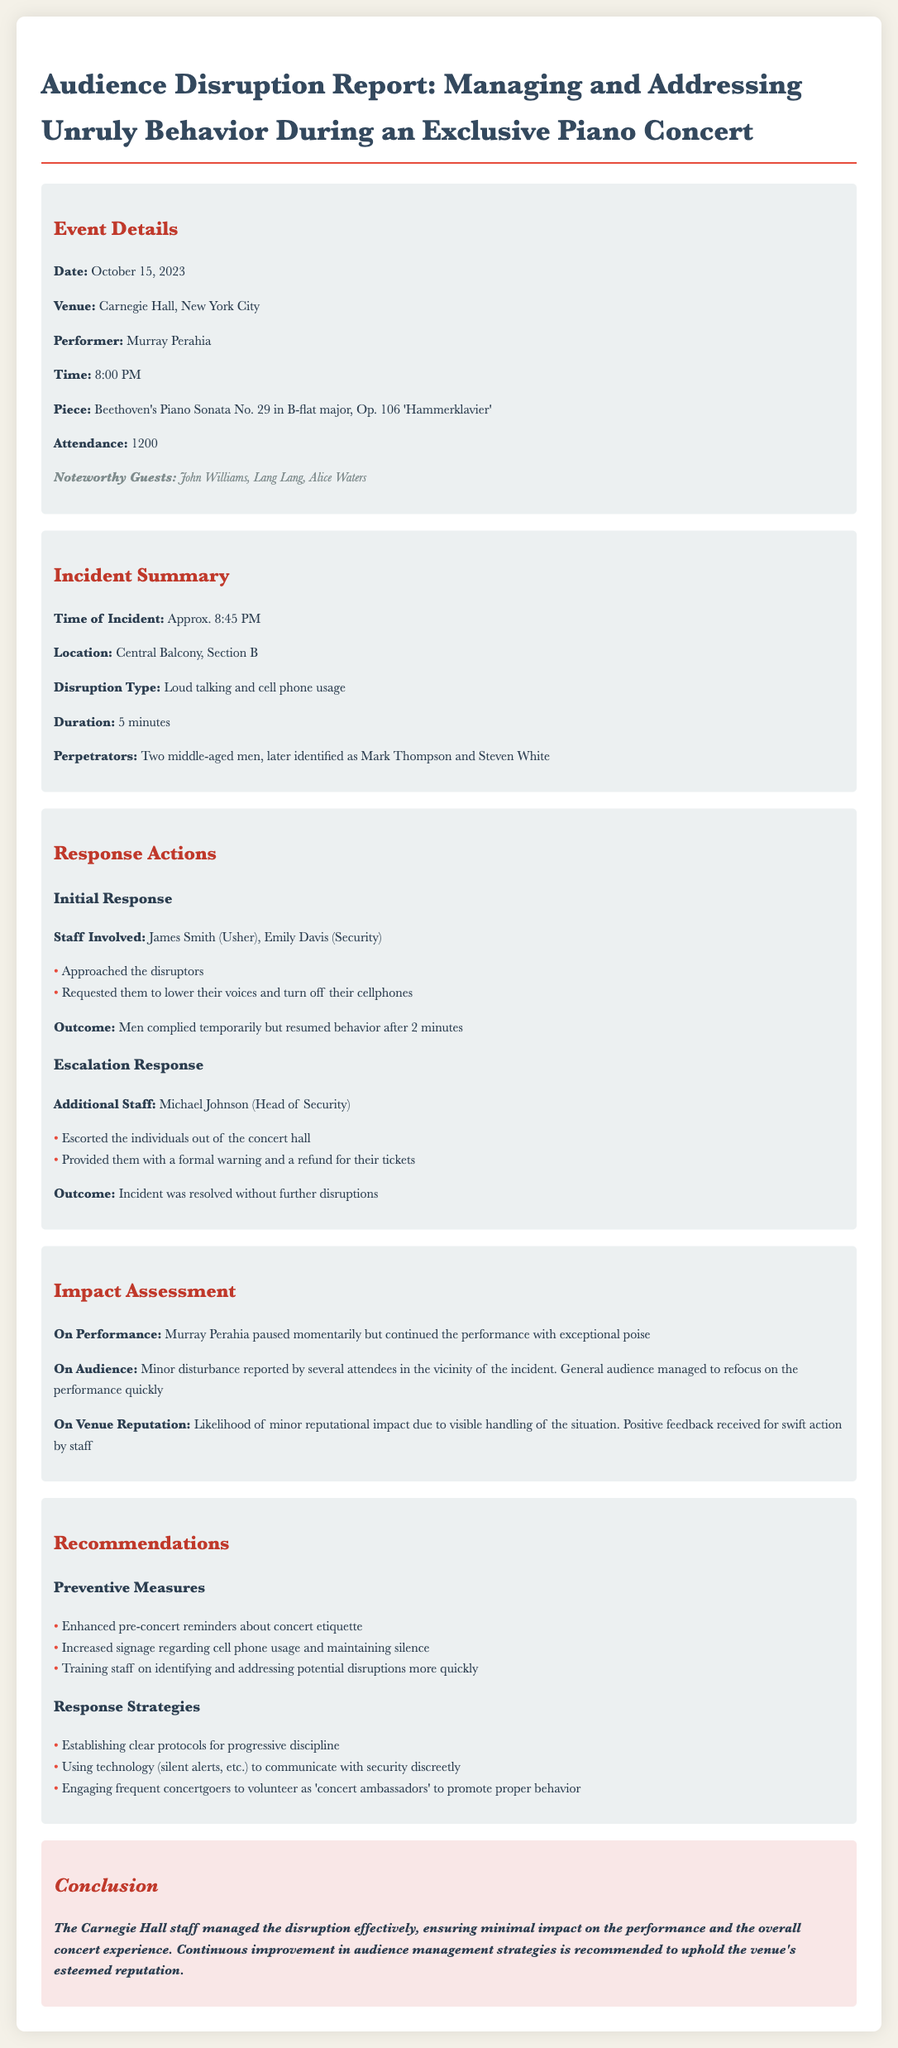what was the date of the concert? The date of the concert is listed in the event details section.
Answer: October 15, 2023 who was the performer at the concert? The performer is mentioned in the event details section of the document.
Answer: Murray Perahia what was the disruption type during the concert? The disruption type is specified in the incident summary.
Answer: Loud talking and cell phone usage what actions were taken in response to the disruption? The response actions outline both initial and escalation responses.
Answer: Approached the disruptors how long did the disruption last? The duration of the disruption is provided in the incident summary.
Answer: 5 minutes what was the outcome of the escalation response? The outcome of the escalation response is detailed in the response actions section.
Answer: Incident was resolved without further disruptions what impact did the incident have on the audience? The impact on the audience is assessed in the impact assessment section.
Answer: Minor disturbance reported what recommendations are suggested for preventive measures? The recommendations section lists several preventive measures.
Answer: Enhanced pre-concert reminders about concert etiquette what was the time of the incident? The time of the incident is mentioned in the incident summary.
Answer: Approx. 8:45 PM who were the perpetrators of the disruption? The perpetrators are identified in the incident summary.
Answer: Mark Thompson and Steven White 